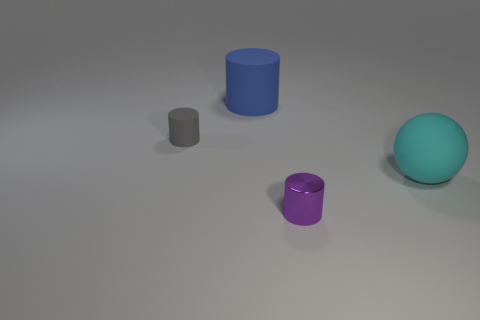Add 3 big matte spheres. How many objects exist? 7 Subtract all balls. How many objects are left? 3 Subtract all rubber balls. Subtract all small gray rubber objects. How many objects are left? 2 Add 1 small purple metallic things. How many small purple metallic things are left? 2 Add 2 tiny purple objects. How many tiny purple objects exist? 3 Subtract 0 blue blocks. How many objects are left? 4 